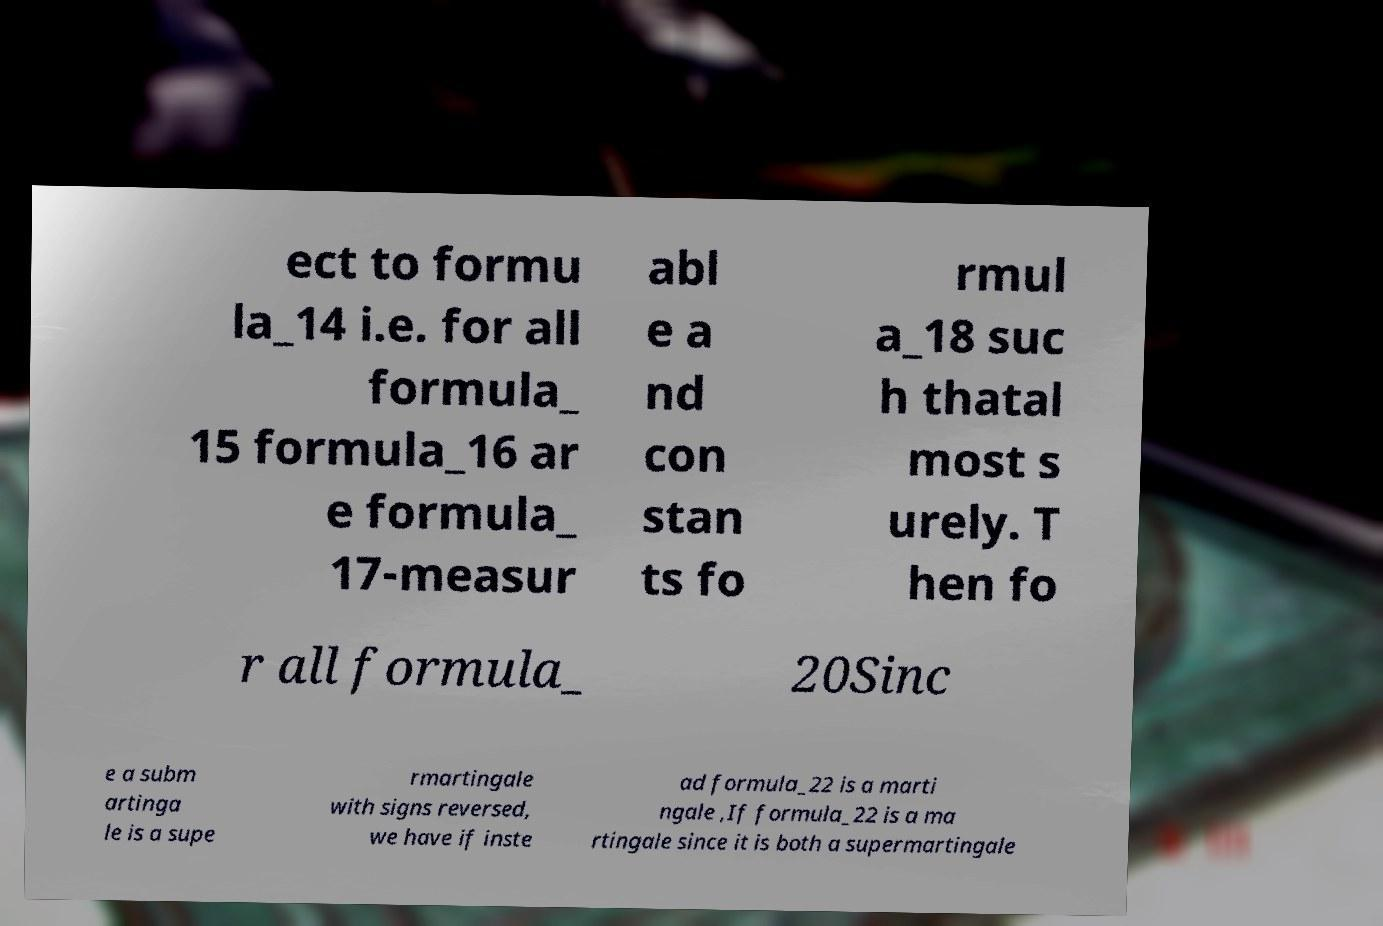Could you extract and type out the text from this image? ect to formu la_14 i.e. for all formula_ 15 formula_16 ar e formula_ 17-measur abl e a nd con stan ts fo rmul a_18 suc h thatal most s urely. T hen fo r all formula_ 20Sinc e a subm artinga le is a supe rmartingale with signs reversed, we have if inste ad formula_22 is a marti ngale ,If formula_22 is a ma rtingale since it is both a supermartingale 